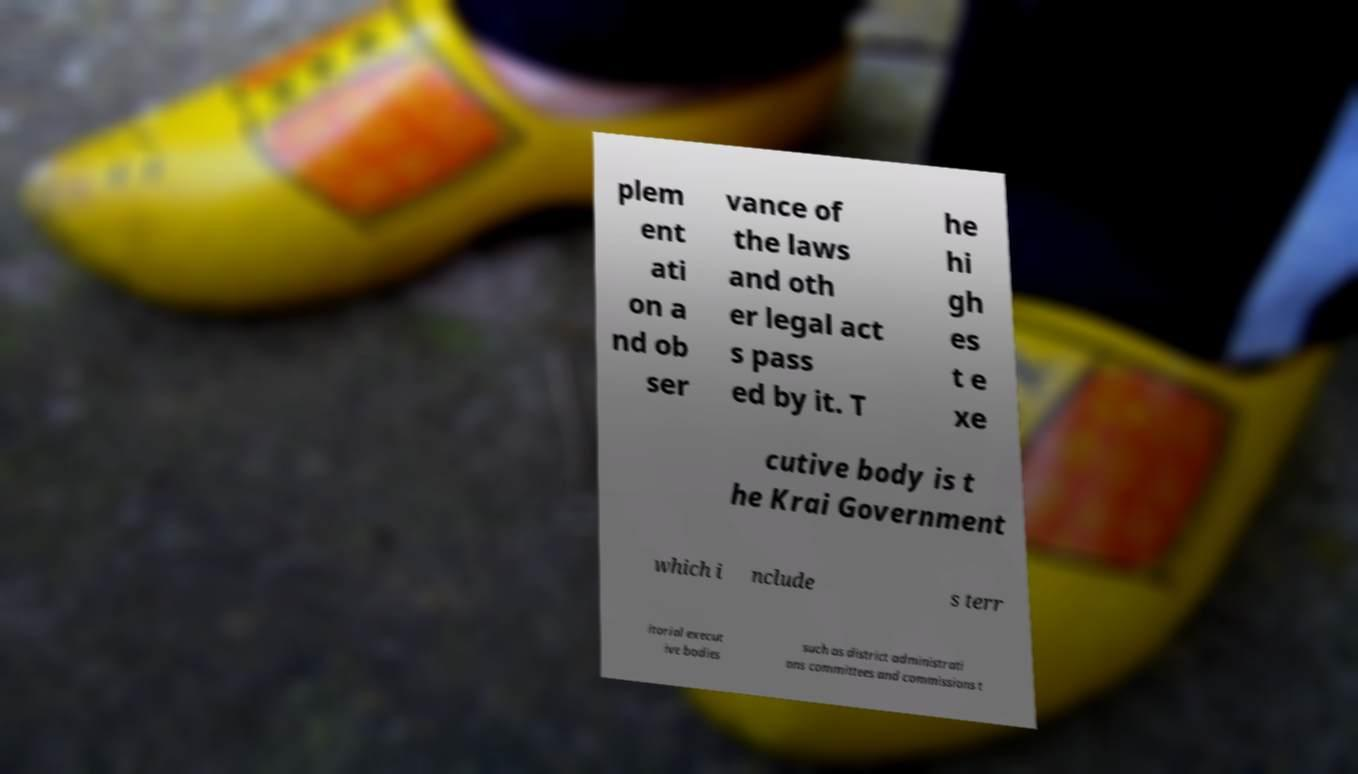Can you accurately transcribe the text from the provided image for me? plem ent ati on a nd ob ser vance of the laws and oth er legal act s pass ed by it. T he hi gh es t e xe cutive body is t he Krai Government which i nclude s terr itorial execut ive bodies such as district administrati ons committees and commissions t 